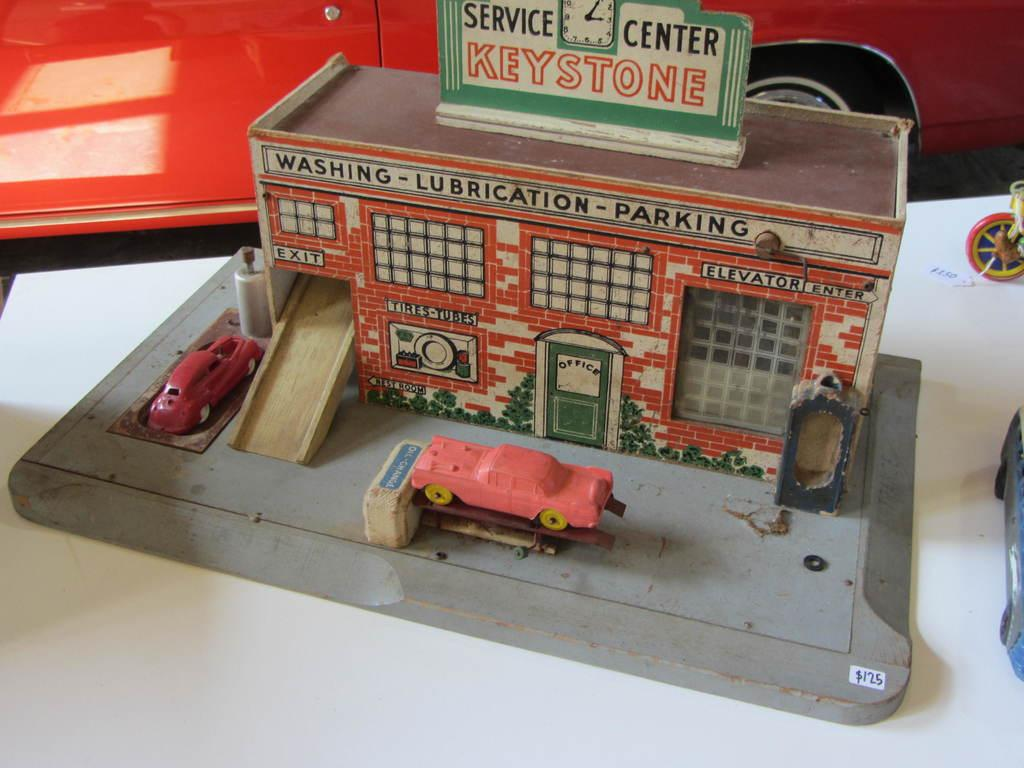What is the main subject on the table in the image? There is a miniature on a table in the image. What else can be seen near the table in the image? There is a car beside the table in the image. What family members are having a discussion about the miniature in the image? There is no indication of a family or a discussion in the image; it only shows a miniature on a table and a car beside it. 